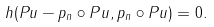<formula> <loc_0><loc_0><loc_500><loc_500>\ h ( P u - p _ { n } \circ P u , p _ { n } \circ P u ) = 0 .</formula> 